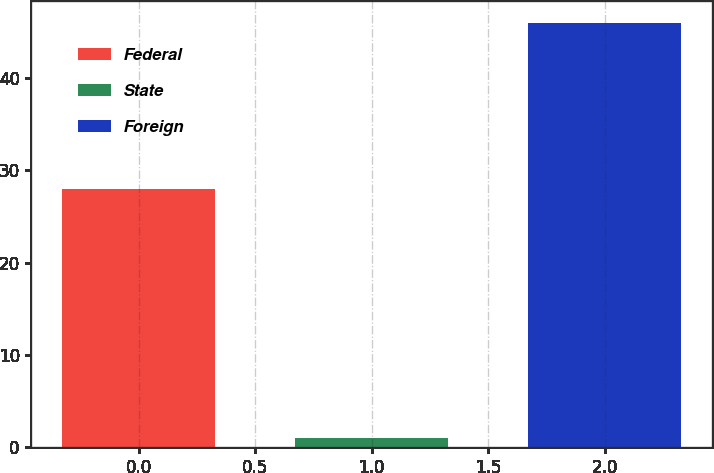<chart> <loc_0><loc_0><loc_500><loc_500><bar_chart><fcel>Federal<fcel>State<fcel>Foreign<nl><fcel>28<fcel>1<fcel>46<nl></chart> 